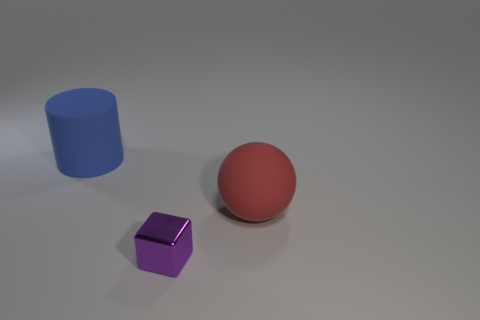Add 2 tiny blue metal things. How many objects exist? 5 Subtract all blocks. How many objects are left? 2 Subtract 0 blue balls. How many objects are left? 3 Subtract all large matte spheres. Subtract all large blue cylinders. How many objects are left? 1 Add 1 large blue matte cylinders. How many large blue matte cylinders are left? 2 Add 2 rubber spheres. How many rubber spheres exist? 3 